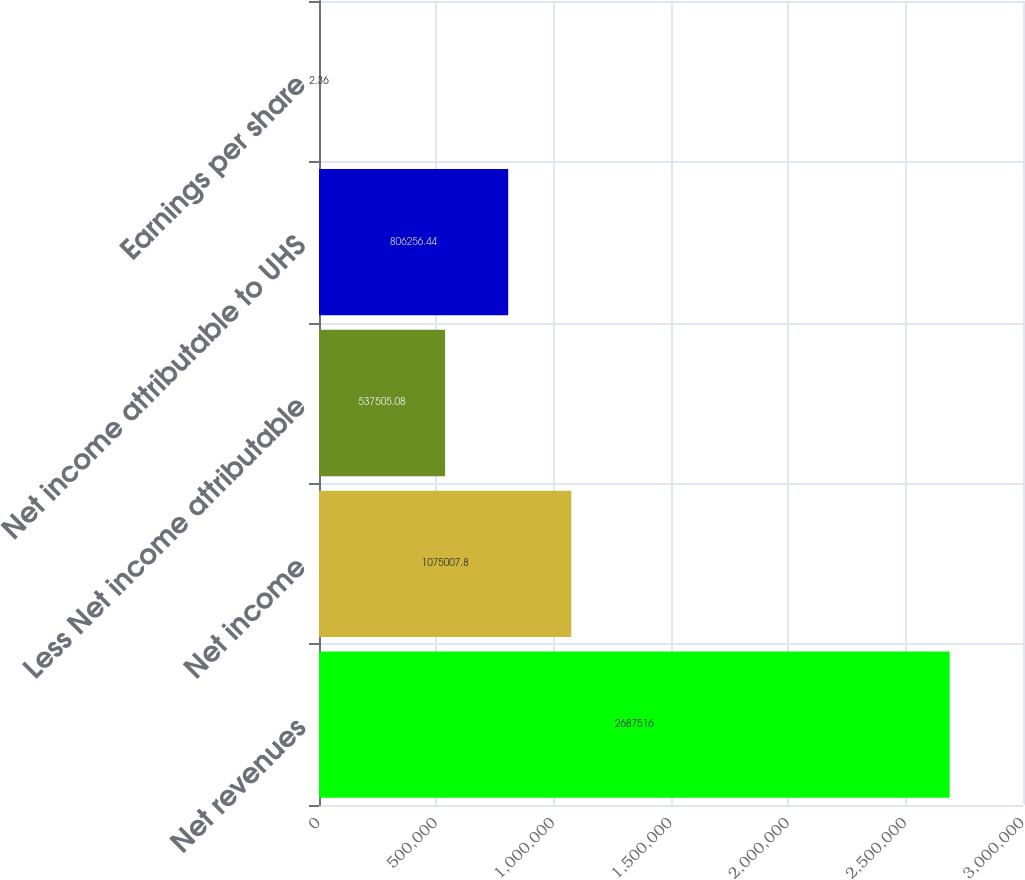Convert chart. <chart><loc_0><loc_0><loc_500><loc_500><bar_chart><fcel>Net revenues<fcel>Net income<fcel>Less Net income attributable<fcel>Net income attributable to UHS<fcel>Earnings per share<nl><fcel>2.68752e+06<fcel>1.07501e+06<fcel>537505<fcel>806256<fcel>2.36<nl></chart> 